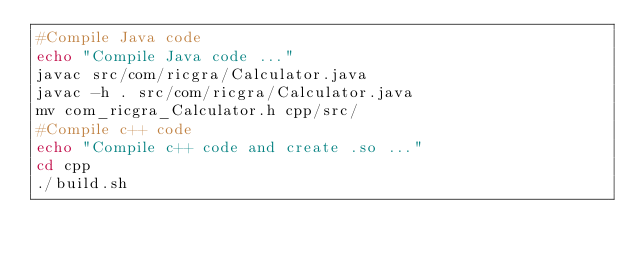Convert code to text. <code><loc_0><loc_0><loc_500><loc_500><_Bash_>#Compile Java code
echo "Compile Java code ..."
javac src/com/ricgra/Calculator.java
javac -h . src/com/ricgra/Calculator.java
mv com_ricgra_Calculator.h cpp/src/
#Compile c++ code
echo "Compile c++ code and create .so ..."
cd cpp
./build.sh
</code> 